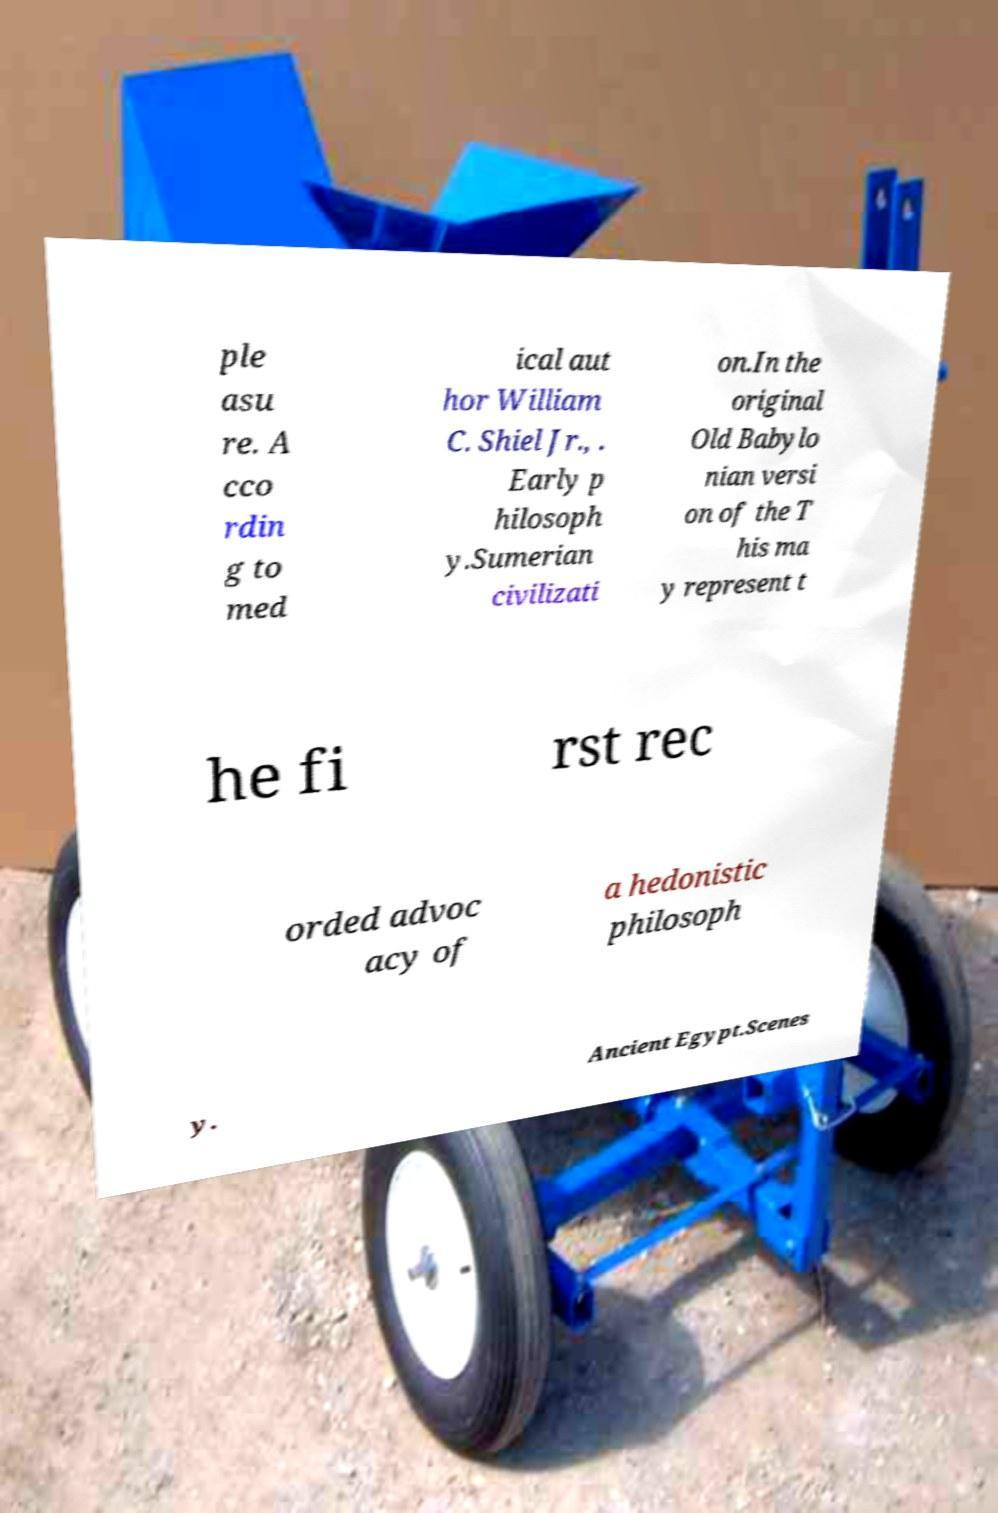What messages or text are displayed in this image? I need them in a readable, typed format. ple asu re. A cco rdin g to med ical aut hor William C. Shiel Jr., . Early p hilosoph y.Sumerian civilizati on.In the original Old Babylo nian versi on of the T his ma y represent t he fi rst rec orded advoc acy of a hedonistic philosoph y. Ancient Egypt.Scenes 